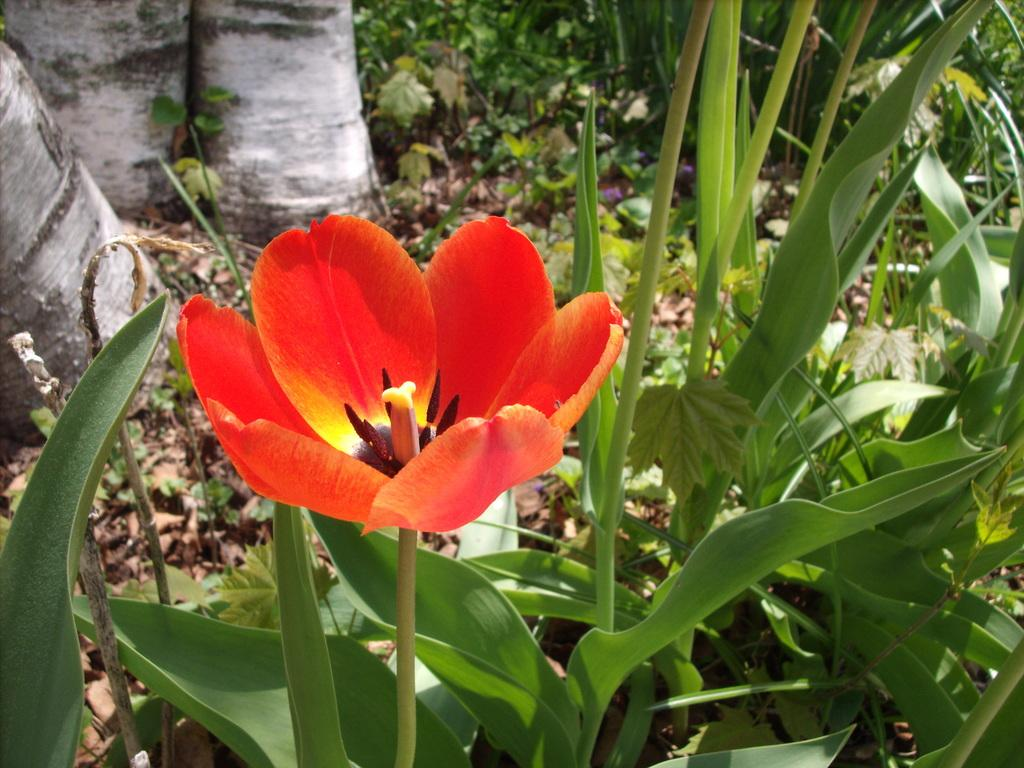What type of plant is visible in the image? There is a flower on a plant in the image. What other vegetation can be seen in the image? Trees are visible in the image. What type of harbor can be seen in the image? There is no harbor present in the image; it features a flower on a plant and trees. What type of vacation destination is depicted in the image? The image does not depict a vacation destination; it features a flower on a plant and trees. 